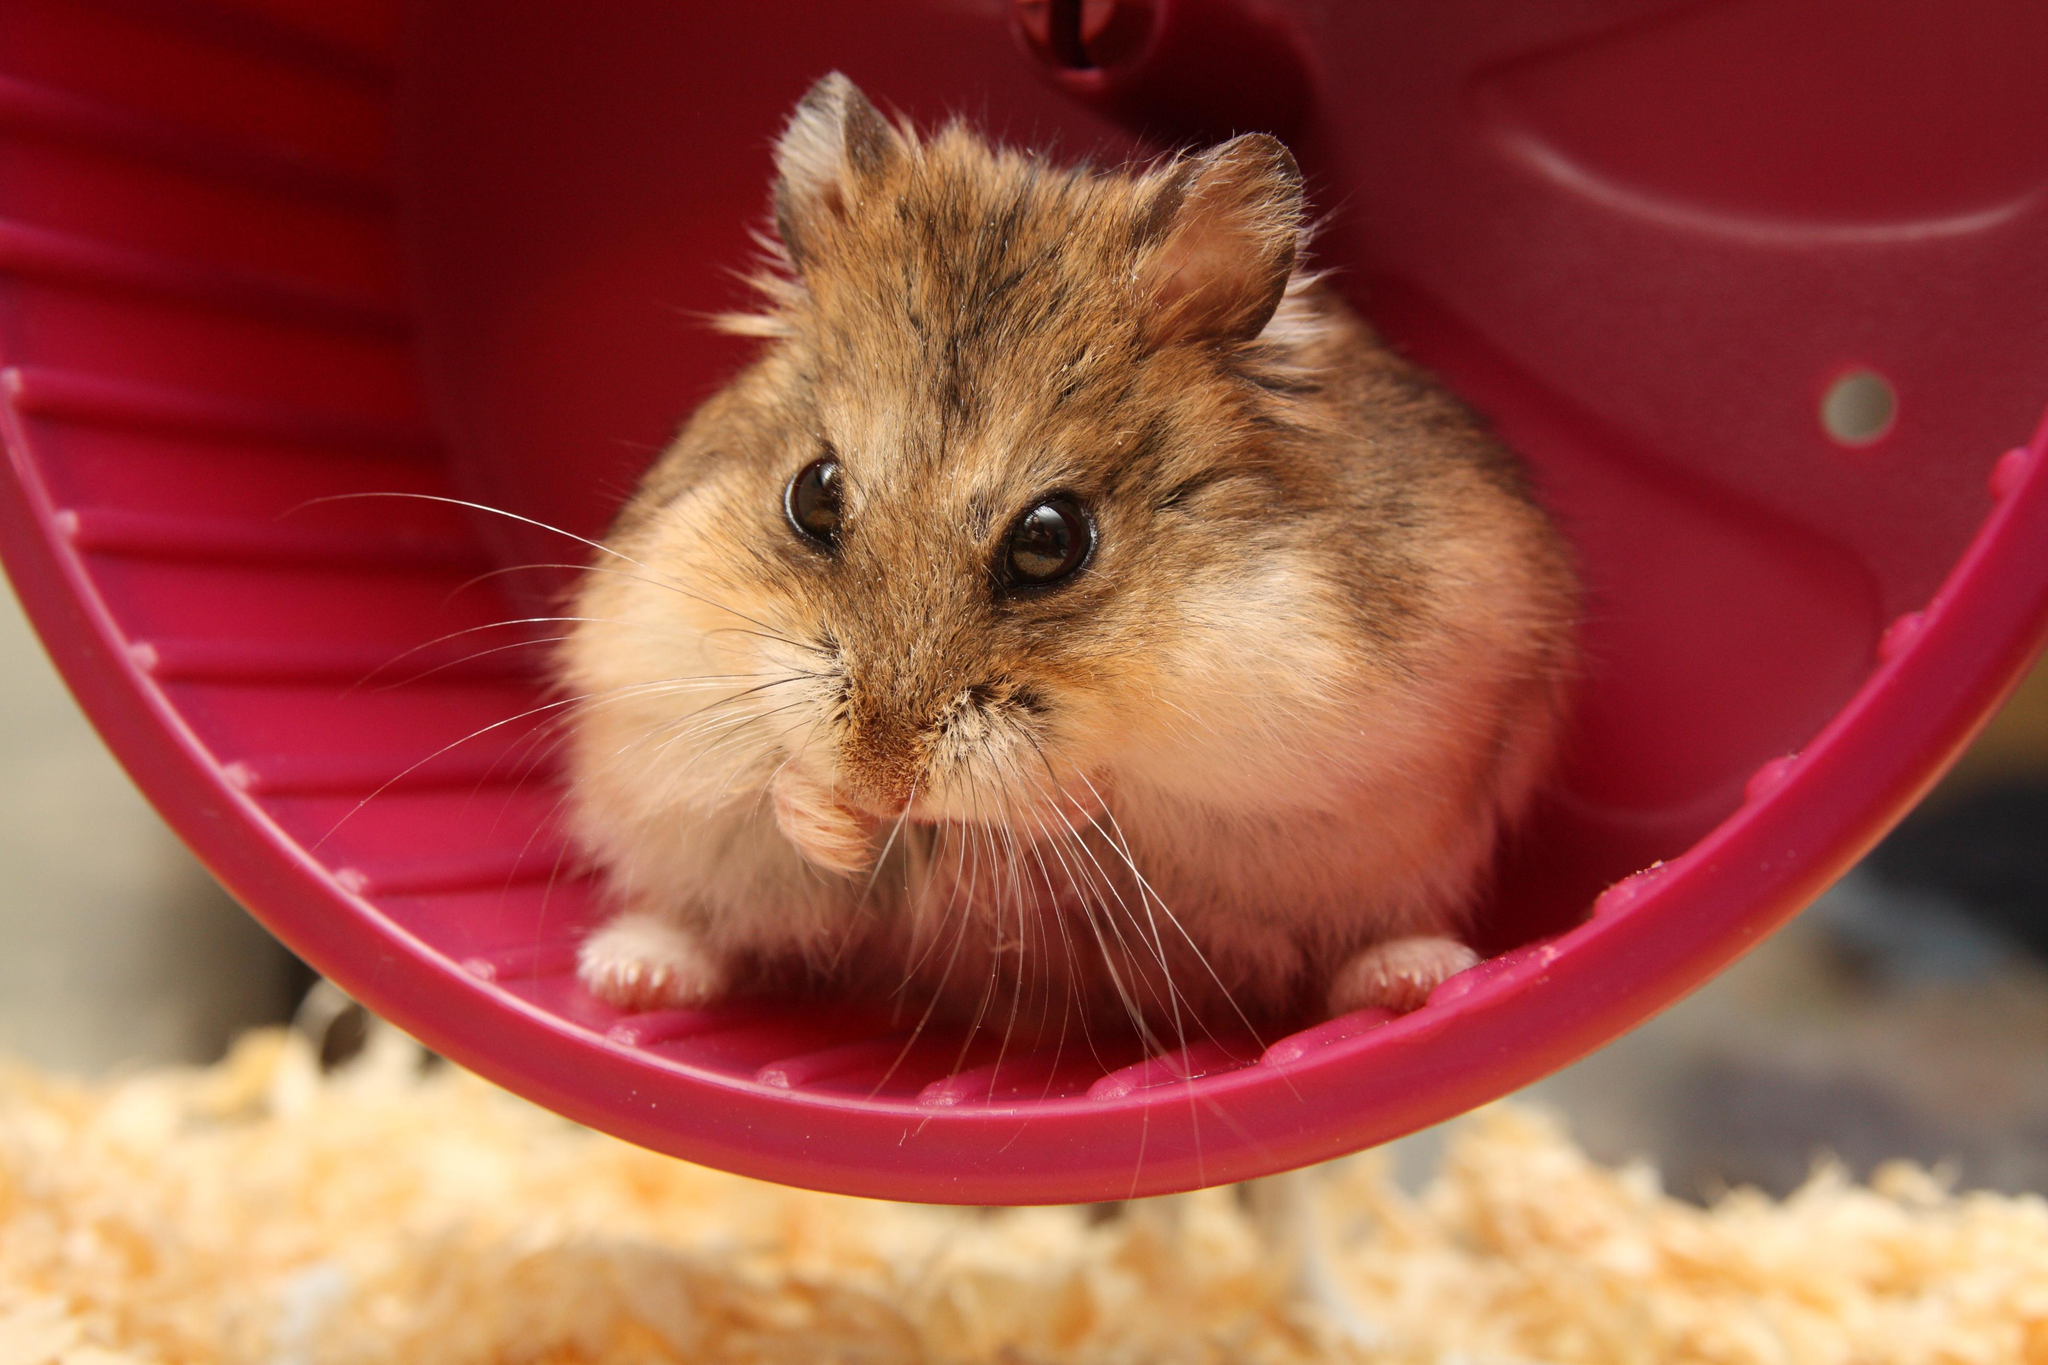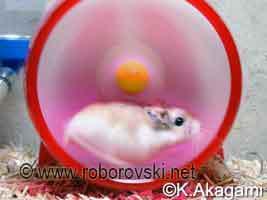The first image is the image on the left, the second image is the image on the right. For the images shown, is this caption "The left image contains a rodent running on a blue hamster wheel." true? Answer yes or no. No. The first image is the image on the left, the second image is the image on the right. Examine the images to the left and right. Is the description "Each image features at least one pet rodent in a wheel, and the wheel on the left is blue while the one on the right is red." accurate? Answer yes or no. No. 